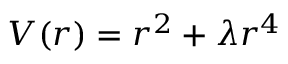Convert formula to latex. <formula><loc_0><loc_0><loc_500><loc_500>V ( r ) = r ^ { 2 } + \lambda r ^ { 4 }</formula> 